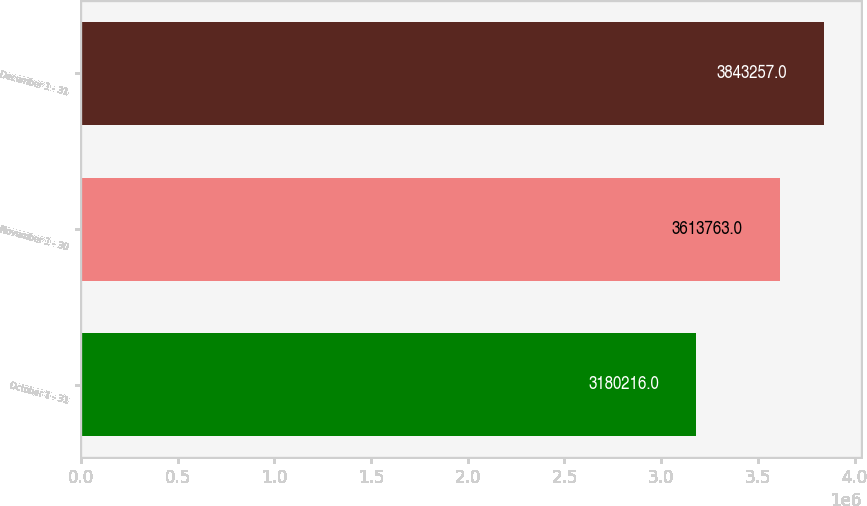Convert chart. <chart><loc_0><loc_0><loc_500><loc_500><bar_chart><fcel>October 1 - 31<fcel>November 1 - 30<fcel>December 1 - 31<nl><fcel>3.18022e+06<fcel>3.61376e+06<fcel>3.84326e+06<nl></chart> 